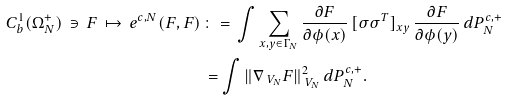<formula> <loc_0><loc_0><loc_500><loc_500>C ^ { 1 } _ { b } ( \Omega _ { N } ^ { + } ) \, \ni \, F \, \mapsto \, e ^ { c , N } ( F , F ) \, & \colon = \, \int \sum _ { x , y \in \Gamma _ { N } } \frac { \partial F } { \partial \phi ( x ) } \, [ \sigma \sigma ^ { T } ] _ { x y } \, \frac { \partial F } { \partial \phi ( y ) } \, d { P } _ { N } ^ { c , + } \\ & = \int \| \nabla _ { \ V _ { N } } F \| ^ { 2 } _ { \ V _ { N } } \, d { P } _ { N } ^ { c , + } .</formula> 